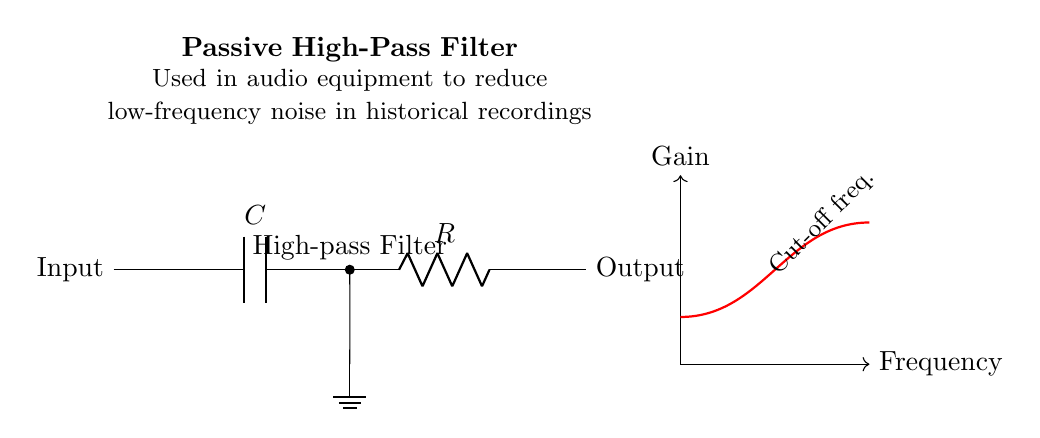What is the type of filter depicted in the circuit? The circuit diagram shows a passive high-pass filter, which is designed to allow high frequencies to pass while attenuating low frequencies. This can be identified by the arrangement of the capacitor and resistor in series.
Answer: high-pass filter What components are used in this circuit? The circuit consists of a capacitor and a resistor, which are the primary components that determine its filtering characteristics. The capacitor blocks low-frequency signals while allowing high-frequency signals to pass through.
Answer: capacitor and resistor What is the purpose of this filter in audio equipment? The purpose of this high-pass filter is to reduce low-frequency noise in historical recordings, making the audio clearer by filtering out unwanted low-frequency sounds that may have been present in old recordings.
Answer: reduce low-frequency noise What happens to signals below the cut-off frequency? Signals that are below the cut-off frequency are attenuated or diminished in amplitude. This means that low-frequency signals will experience a significant reduction as they pass through the filter.
Answer: attenuated What is represented on the horizontal axis of the frequency response graph? The horizontal axis of the frequency response graph represents frequency, indicating how different frequencies affect the gain of the circuit. It provides insight into the filter's behavior across the frequency spectrum.
Answer: frequency What is the significance of the cut-off frequency in this filter? The cut-off frequency is the point at which the filter starts to significantly attenuate signals; it is crucial for determining what frequencies are allowed to pass through the filter and which ones are eliminated. This frequency determines the filter's effectiveness in audio applications.
Answer: point of significant attenuation 